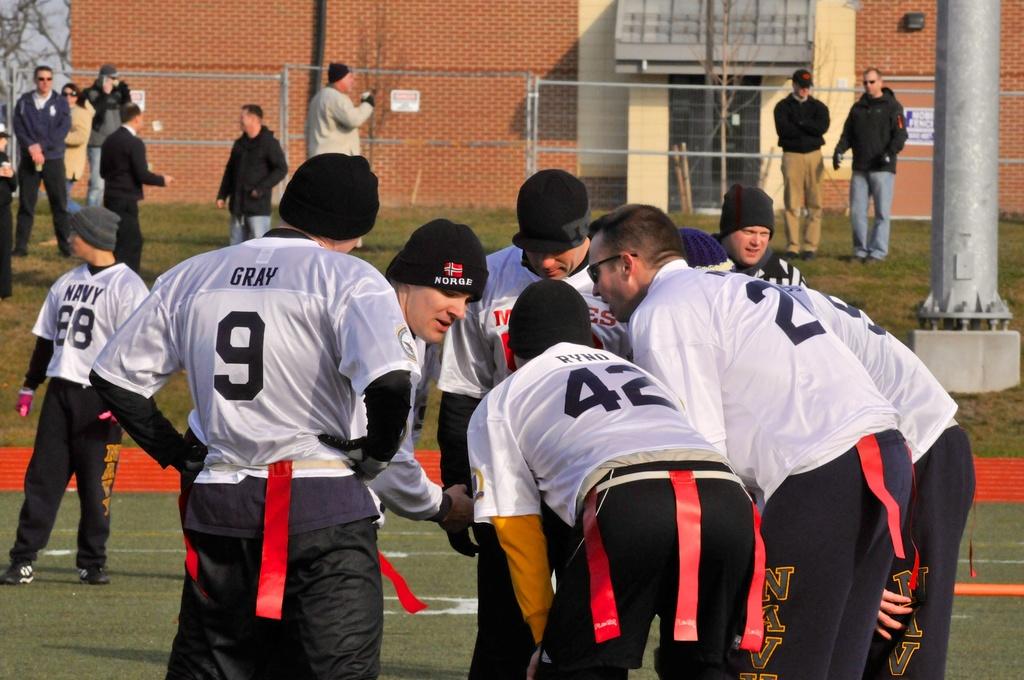What does their hats say?
Your answer should be very brief. Norge. 